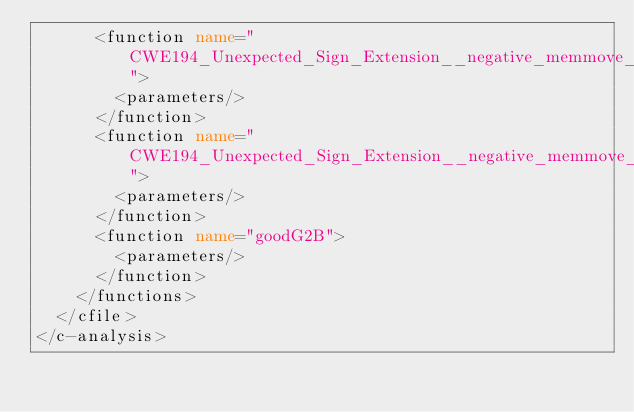<code> <loc_0><loc_0><loc_500><loc_500><_XML_>      <function name="CWE194_Unexpected_Sign_Extension__negative_memmove_52_bad">
        <parameters/>
      </function>
      <function name="CWE194_Unexpected_Sign_Extension__negative_memmove_52_good">
        <parameters/>
      </function>
      <function name="goodG2B">
        <parameters/>
      </function>
    </functions>
  </cfile>
</c-analysis>
</code> 